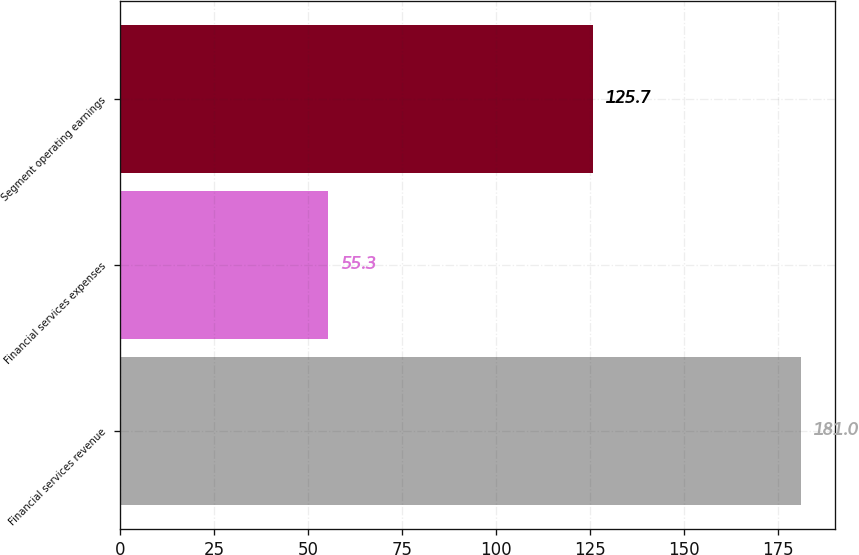<chart> <loc_0><loc_0><loc_500><loc_500><bar_chart><fcel>Financial services revenue<fcel>Financial services expenses<fcel>Segment operating earnings<nl><fcel>181<fcel>55.3<fcel>125.7<nl></chart> 